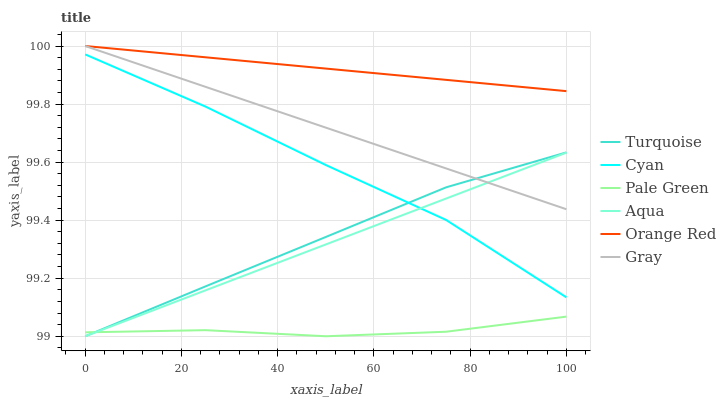Does Pale Green have the minimum area under the curve?
Answer yes or no. Yes. Does Orange Red have the maximum area under the curve?
Answer yes or no. Yes. Does Turquoise have the minimum area under the curve?
Answer yes or no. No. Does Turquoise have the maximum area under the curve?
Answer yes or no. No. Is Aqua the smoothest?
Answer yes or no. Yes. Is Cyan the roughest?
Answer yes or no. Yes. Is Turquoise the smoothest?
Answer yes or no. No. Is Turquoise the roughest?
Answer yes or no. No. Does Cyan have the lowest value?
Answer yes or no. No. Does Turquoise have the highest value?
Answer yes or no. No. Is Cyan less than Gray?
Answer yes or no. Yes. Is Orange Red greater than Turquoise?
Answer yes or no. Yes. Does Cyan intersect Gray?
Answer yes or no. No. 